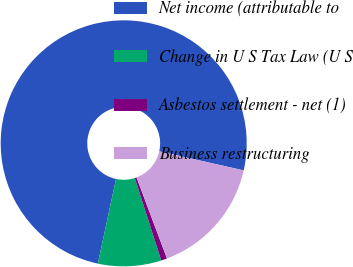Convert chart. <chart><loc_0><loc_0><loc_500><loc_500><pie_chart><fcel>Net income (attributable to<fcel>Change in U S Tax Law (U S<fcel>Asbestos settlement - net (1)<fcel>Business restructuring<nl><fcel>75.16%<fcel>8.31%<fcel>0.78%<fcel>15.75%<nl></chart> 